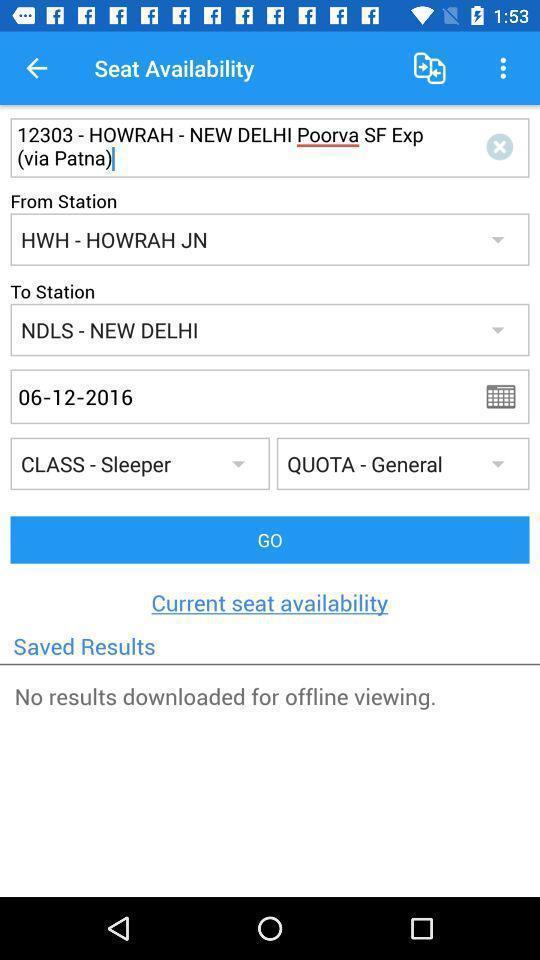Describe this image in words. Search page of train booking in travel booking app. 